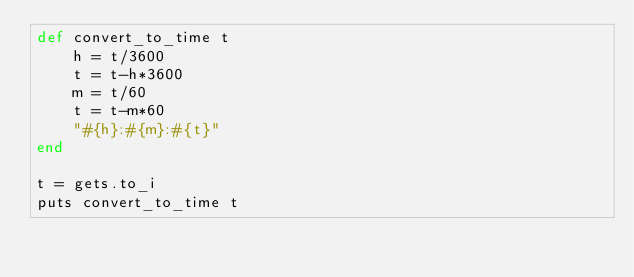<code> <loc_0><loc_0><loc_500><loc_500><_Ruby_>def convert_to_time t
	h = t/3600
	t = t-h*3600
	m = t/60
	t = t-m*60
	"#{h}:#{m}:#{t}"
end

t = gets.to_i
puts convert_to_time t</code> 